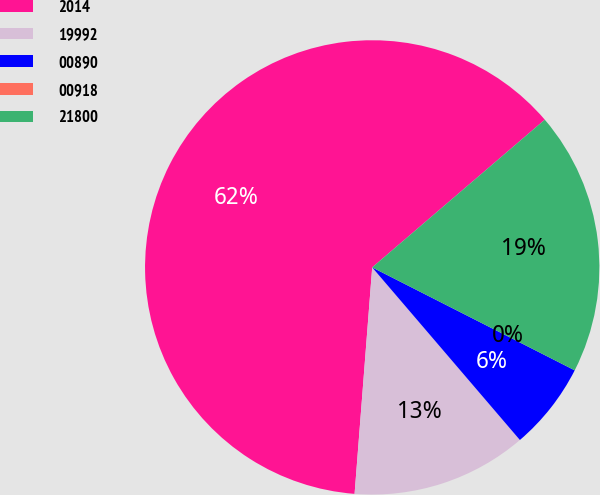Convert chart to OTSL. <chart><loc_0><loc_0><loc_500><loc_500><pie_chart><fcel>2014<fcel>19992<fcel>00890<fcel>00918<fcel>21800<nl><fcel>62.49%<fcel>12.5%<fcel>6.25%<fcel>0.0%<fcel>18.75%<nl></chart> 